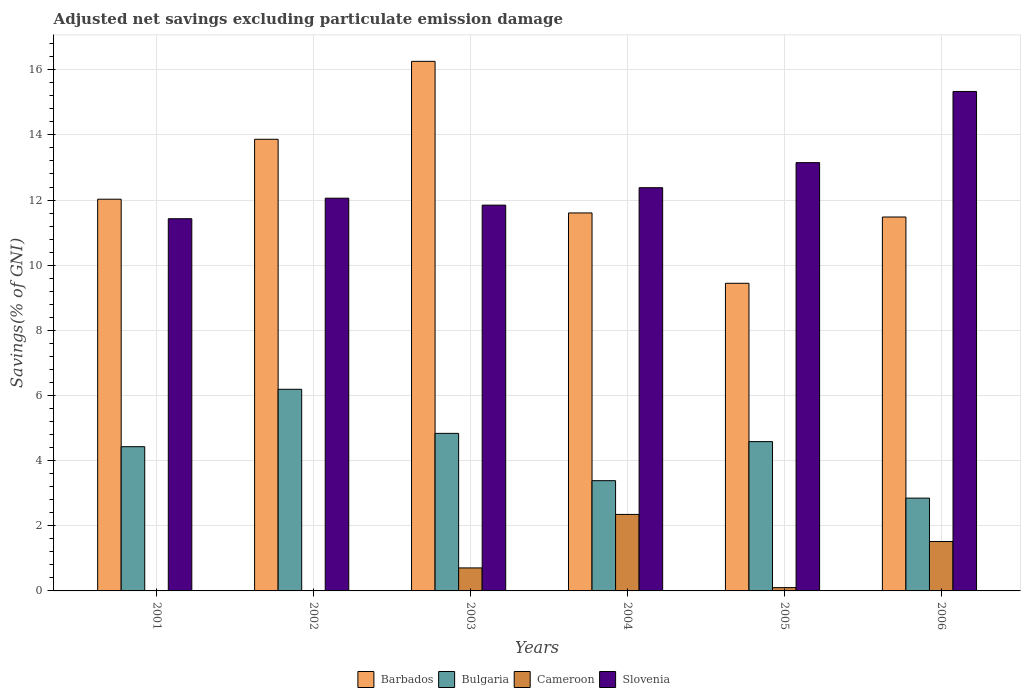How many groups of bars are there?
Provide a short and direct response. 6. How many bars are there on the 1st tick from the left?
Provide a short and direct response. 3. What is the adjusted net savings in Bulgaria in 2001?
Make the answer very short. 4.43. Across all years, what is the maximum adjusted net savings in Bulgaria?
Offer a very short reply. 6.19. Across all years, what is the minimum adjusted net savings in Slovenia?
Your response must be concise. 11.43. What is the total adjusted net savings in Barbados in the graph?
Offer a very short reply. 74.67. What is the difference between the adjusted net savings in Barbados in 2004 and that in 2006?
Your response must be concise. 0.12. What is the difference between the adjusted net savings in Barbados in 2005 and the adjusted net savings in Bulgaria in 2004?
Make the answer very short. 6.06. What is the average adjusted net savings in Barbados per year?
Make the answer very short. 12.45. In the year 2006, what is the difference between the adjusted net savings in Slovenia and adjusted net savings in Barbados?
Ensure brevity in your answer.  3.85. In how many years, is the adjusted net savings in Cameroon greater than 5.6 %?
Your response must be concise. 0. What is the ratio of the adjusted net savings in Cameroon in 2004 to that in 2005?
Your response must be concise. 23.28. Is the adjusted net savings in Barbados in 2001 less than that in 2002?
Give a very brief answer. Yes. Is the difference between the adjusted net savings in Slovenia in 2002 and 2006 greater than the difference between the adjusted net savings in Barbados in 2002 and 2006?
Keep it short and to the point. No. What is the difference between the highest and the second highest adjusted net savings in Slovenia?
Offer a very short reply. 2.19. What is the difference between the highest and the lowest adjusted net savings in Barbados?
Offer a very short reply. 6.81. Are all the bars in the graph horizontal?
Keep it short and to the point. No. Are the values on the major ticks of Y-axis written in scientific E-notation?
Give a very brief answer. No. Does the graph contain grids?
Offer a terse response. Yes. How are the legend labels stacked?
Keep it short and to the point. Horizontal. What is the title of the graph?
Offer a very short reply. Adjusted net savings excluding particulate emission damage. Does "Burkina Faso" appear as one of the legend labels in the graph?
Provide a short and direct response. No. What is the label or title of the Y-axis?
Keep it short and to the point. Savings(% of GNI). What is the Savings(% of GNI) in Barbados in 2001?
Your response must be concise. 12.03. What is the Savings(% of GNI) in Bulgaria in 2001?
Your answer should be very brief. 4.43. What is the Savings(% of GNI) of Cameroon in 2001?
Ensure brevity in your answer.  0. What is the Savings(% of GNI) in Slovenia in 2001?
Your answer should be very brief. 11.43. What is the Savings(% of GNI) of Barbados in 2002?
Keep it short and to the point. 13.87. What is the Savings(% of GNI) of Bulgaria in 2002?
Keep it short and to the point. 6.19. What is the Savings(% of GNI) of Cameroon in 2002?
Give a very brief answer. 0. What is the Savings(% of GNI) of Slovenia in 2002?
Offer a very short reply. 12.06. What is the Savings(% of GNI) of Barbados in 2003?
Your answer should be very brief. 16.26. What is the Savings(% of GNI) of Bulgaria in 2003?
Keep it short and to the point. 4.84. What is the Savings(% of GNI) of Cameroon in 2003?
Provide a short and direct response. 0.71. What is the Savings(% of GNI) in Slovenia in 2003?
Provide a short and direct response. 11.84. What is the Savings(% of GNI) of Barbados in 2004?
Ensure brevity in your answer.  11.6. What is the Savings(% of GNI) of Bulgaria in 2004?
Offer a terse response. 3.38. What is the Savings(% of GNI) of Cameroon in 2004?
Give a very brief answer. 2.35. What is the Savings(% of GNI) of Slovenia in 2004?
Your answer should be very brief. 12.38. What is the Savings(% of GNI) in Barbados in 2005?
Provide a short and direct response. 9.44. What is the Savings(% of GNI) of Bulgaria in 2005?
Offer a very short reply. 4.58. What is the Savings(% of GNI) of Cameroon in 2005?
Ensure brevity in your answer.  0.1. What is the Savings(% of GNI) in Slovenia in 2005?
Provide a succinct answer. 13.15. What is the Savings(% of GNI) of Barbados in 2006?
Make the answer very short. 11.48. What is the Savings(% of GNI) of Bulgaria in 2006?
Provide a succinct answer. 2.85. What is the Savings(% of GNI) in Cameroon in 2006?
Your response must be concise. 1.52. What is the Savings(% of GNI) of Slovenia in 2006?
Your response must be concise. 15.33. Across all years, what is the maximum Savings(% of GNI) in Barbados?
Give a very brief answer. 16.26. Across all years, what is the maximum Savings(% of GNI) in Bulgaria?
Your answer should be compact. 6.19. Across all years, what is the maximum Savings(% of GNI) in Cameroon?
Your response must be concise. 2.35. Across all years, what is the maximum Savings(% of GNI) of Slovenia?
Keep it short and to the point. 15.33. Across all years, what is the minimum Savings(% of GNI) in Barbados?
Keep it short and to the point. 9.44. Across all years, what is the minimum Savings(% of GNI) of Bulgaria?
Your response must be concise. 2.85. Across all years, what is the minimum Savings(% of GNI) in Cameroon?
Your response must be concise. 0. Across all years, what is the minimum Savings(% of GNI) in Slovenia?
Keep it short and to the point. 11.43. What is the total Savings(% of GNI) in Barbados in the graph?
Offer a terse response. 74.67. What is the total Savings(% of GNI) of Bulgaria in the graph?
Your response must be concise. 26.27. What is the total Savings(% of GNI) in Cameroon in the graph?
Your answer should be compact. 4.67. What is the total Savings(% of GNI) of Slovenia in the graph?
Your response must be concise. 76.19. What is the difference between the Savings(% of GNI) of Barbados in 2001 and that in 2002?
Provide a succinct answer. -1.84. What is the difference between the Savings(% of GNI) of Bulgaria in 2001 and that in 2002?
Give a very brief answer. -1.76. What is the difference between the Savings(% of GNI) in Slovenia in 2001 and that in 2002?
Your answer should be compact. -0.63. What is the difference between the Savings(% of GNI) of Barbados in 2001 and that in 2003?
Your answer should be compact. -4.23. What is the difference between the Savings(% of GNI) in Bulgaria in 2001 and that in 2003?
Give a very brief answer. -0.41. What is the difference between the Savings(% of GNI) of Slovenia in 2001 and that in 2003?
Provide a succinct answer. -0.42. What is the difference between the Savings(% of GNI) in Barbados in 2001 and that in 2004?
Ensure brevity in your answer.  0.42. What is the difference between the Savings(% of GNI) of Bulgaria in 2001 and that in 2004?
Offer a terse response. 1.04. What is the difference between the Savings(% of GNI) of Slovenia in 2001 and that in 2004?
Give a very brief answer. -0.95. What is the difference between the Savings(% of GNI) in Barbados in 2001 and that in 2005?
Ensure brevity in your answer.  2.58. What is the difference between the Savings(% of GNI) in Bulgaria in 2001 and that in 2005?
Your answer should be very brief. -0.16. What is the difference between the Savings(% of GNI) in Slovenia in 2001 and that in 2005?
Ensure brevity in your answer.  -1.72. What is the difference between the Savings(% of GNI) of Barbados in 2001 and that in 2006?
Offer a very short reply. 0.55. What is the difference between the Savings(% of GNI) of Bulgaria in 2001 and that in 2006?
Ensure brevity in your answer.  1.58. What is the difference between the Savings(% of GNI) of Slovenia in 2001 and that in 2006?
Offer a very short reply. -3.91. What is the difference between the Savings(% of GNI) of Barbados in 2002 and that in 2003?
Provide a succinct answer. -2.39. What is the difference between the Savings(% of GNI) in Bulgaria in 2002 and that in 2003?
Give a very brief answer. 1.35. What is the difference between the Savings(% of GNI) in Slovenia in 2002 and that in 2003?
Provide a short and direct response. 0.21. What is the difference between the Savings(% of GNI) of Barbados in 2002 and that in 2004?
Keep it short and to the point. 2.26. What is the difference between the Savings(% of GNI) in Bulgaria in 2002 and that in 2004?
Give a very brief answer. 2.81. What is the difference between the Savings(% of GNI) in Slovenia in 2002 and that in 2004?
Your response must be concise. -0.32. What is the difference between the Savings(% of GNI) in Barbados in 2002 and that in 2005?
Your answer should be compact. 4.42. What is the difference between the Savings(% of GNI) in Bulgaria in 2002 and that in 2005?
Offer a terse response. 1.61. What is the difference between the Savings(% of GNI) of Slovenia in 2002 and that in 2005?
Keep it short and to the point. -1.09. What is the difference between the Savings(% of GNI) in Barbados in 2002 and that in 2006?
Keep it short and to the point. 2.39. What is the difference between the Savings(% of GNI) in Bulgaria in 2002 and that in 2006?
Ensure brevity in your answer.  3.34. What is the difference between the Savings(% of GNI) in Slovenia in 2002 and that in 2006?
Your answer should be very brief. -3.28. What is the difference between the Savings(% of GNI) in Barbados in 2003 and that in 2004?
Provide a short and direct response. 4.65. What is the difference between the Savings(% of GNI) of Bulgaria in 2003 and that in 2004?
Keep it short and to the point. 1.45. What is the difference between the Savings(% of GNI) of Cameroon in 2003 and that in 2004?
Your answer should be compact. -1.64. What is the difference between the Savings(% of GNI) in Slovenia in 2003 and that in 2004?
Your answer should be compact. -0.54. What is the difference between the Savings(% of GNI) of Barbados in 2003 and that in 2005?
Ensure brevity in your answer.  6.81. What is the difference between the Savings(% of GNI) of Bulgaria in 2003 and that in 2005?
Give a very brief answer. 0.25. What is the difference between the Savings(% of GNI) of Cameroon in 2003 and that in 2005?
Keep it short and to the point. 0.61. What is the difference between the Savings(% of GNI) of Slovenia in 2003 and that in 2005?
Ensure brevity in your answer.  -1.3. What is the difference between the Savings(% of GNI) of Barbados in 2003 and that in 2006?
Keep it short and to the point. 4.78. What is the difference between the Savings(% of GNI) in Bulgaria in 2003 and that in 2006?
Offer a very short reply. 1.99. What is the difference between the Savings(% of GNI) in Cameroon in 2003 and that in 2006?
Offer a very short reply. -0.81. What is the difference between the Savings(% of GNI) in Slovenia in 2003 and that in 2006?
Provide a short and direct response. -3.49. What is the difference between the Savings(% of GNI) in Barbados in 2004 and that in 2005?
Offer a terse response. 2.16. What is the difference between the Savings(% of GNI) of Bulgaria in 2004 and that in 2005?
Provide a succinct answer. -1.2. What is the difference between the Savings(% of GNI) of Cameroon in 2004 and that in 2005?
Make the answer very short. 2.25. What is the difference between the Savings(% of GNI) in Slovenia in 2004 and that in 2005?
Your answer should be very brief. -0.77. What is the difference between the Savings(% of GNI) of Barbados in 2004 and that in 2006?
Provide a short and direct response. 0.12. What is the difference between the Savings(% of GNI) in Bulgaria in 2004 and that in 2006?
Your answer should be compact. 0.54. What is the difference between the Savings(% of GNI) in Cameroon in 2004 and that in 2006?
Your response must be concise. 0.83. What is the difference between the Savings(% of GNI) of Slovenia in 2004 and that in 2006?
Ensure brevity in your answer.  -2.95. What is the difference between the Savings(% of GNI) of Barbados in 2005 and that in 2006?
Keep it short and to the point. -2.03. What is the difference between the Savings(% of GNI) of Bulgaria in 2005 and that in 2006?
Give a very brief answer. 1.73. What is the difference between the Savings(% of GNI) in Cameroon in 2005 and that in 2006?
Your answer should be compact. -1.42. What is the difference between the Savings(% of GNI) of Slovenia in 2005 and that in 2006?
Your answer should be very brief. -2.19. What is the difference between the Savings(% of GNI) of Barbados in 2001 and the Savings(% of GNI) of Bulgaria in 2002?
Your response must be concise. 5.84. What is the difference between the Savings(% of GNI) of Barbados in 2001 and the Savings(% of GNI) of Slovenia in 2002?
Ensure brevity in your answer.  -0.03. What is the difference between the Savings(% of GNI) of Bulgaria in 2001 and the Savings(% of GNI) of Slovenia in 2002?
Provide a succinct answer. -7.63. What is the difference between the Savings(% of GNI) in Barbados in 2001 and the Savings(% of GNI) in Bulgaria in 2003?
Give a very brief answer. 7.19. What is the difference between the Savings(% of GNI) in Barbados in 2001 and the Savings(% of GNI) in Cameroon in 2003?
Your response must be concise. 11.32. What is the difference between the Savings(% of GNI) in Barbados in 2001 and the Savings(% of GNI) in Slovenia in 2003?
Give a very brief answer. 0.18. What is the difference between the Savings(% of GNI) in Bulgaria in 2001 and the Savings(% of GNI) in Cameroon in 2003?
Offer a terse response. 3.72. What is the difference between the Savings(% of GNI) of Bulgaria in 2001 and the Savings(% of GNI) of Slovenia in 2003?
Keep it short and to the point. -7.42. What is the difference between the Savings(% of GNI) of Barbados in 2001 and the Savings(% of GNI) of Bulgaria in 2004?
Your answer should be compact. 8.64. What is the difference between the Savings(% of GNI) of Barbados in 2001 and the Savings(% of GNI) of Cameroon in 2004?
Ensure brevity in your answer.  9.68. What is the difference between the Savings(% of GNI) in Barbados in 2001 and the Savings(% of GNI) in Slovenia in 2004?
Your response must be concise. -0.35. What is the difference between the Savings(% of GNI) in Bulgaria in 2001 and the Savings(% of GNI) in Cameroon in 2004?
Provide a short and direct response. 2.08. What is the difference between the Savings(% of GNI) of Bulgaria in 2001 and the Savings(% of GNI) of Slovenia in 2004?
Your answer should be compact. -7.95. What is the difference between the Savings(% of GNI) in Barbados in 2001 and the Savings(% of GNI) in Bulgaria in 2005?
Your response must be concise. 7.44. What is the difference between the Savings(% of GNI) of Barbados in 2001 and the Savings(% of GNI) of Cameroon in 2005?
Offer a terse response. 11.92. What is the difference between the Savings(% of GNI) of Barbados in 2001 and the Savings(% of GNI) of Slovenia in 2005?
Your answer should be compact. -1.12. What is the difference between the Savings(% of GNI) of Bulgaria in 2001 and the Savings(% of GNI) of Cameroon in 2005?
Keep it short and to the point. 4.33. What is the difference between the Savings(% of GNI) in Bulgaria in 2001 and the Savings(% of GNI) in Slovenia in 2005?
Your answer should be very brief. -8.72. What is the difference between the Savings(% of GNI) in Barbados in 2001 and the Savings(% of GNI) in Bulgaria in 2006?
Your answer should be very brief. 9.18. What is the difference between the Savings(% of GNI) of Barbados in 2001 and the Savings(% of GNI) of Cameroon in 2006?
Your answer should be compact. 10.51. What is the difference between the Savings(% of GNI) in Barbados in 2001 and the Savings(% of GNI) in Slovenia in 2006?
Your response must be concise. -3.31. What is the difference between the Savings(% of GNI) of Bulgaria in 2001 and the Savings(% of GNI) of Cameroon in 2006?
Your answer should be very brief. 2.91. What is the difference between the Savings(% of GNI) in Bulgaria in 2001 and the Savings(% of GNI) in Slovenia in 2006?
Give a very brief answer. -10.91. What is the difference between the Savings(% of GNI) in Barbados in 2002 and the Savings(% of GNI) in Bulgaria in 2003?
Ensure brevity in your answer.  9.03. What is the difference between the Savings(% of GNI) in Barbados in 2002 and the Savings(% of GNI) in Cameroon in 2003?
Make the answer very short. 13.16. What is the difference between the Savings(% of GNI) in Barbados in 2002 and the Savings(% of GNI) in Slovenia in 2003?
Provide a short and direct response. 2.02. What is the difference between the Savings(% of GNI) in Bulgaria in 2002 and the Savings(% of GNI) in Cameroon in 2003?
Your response must be concise. 5.48. What is the difference between the Savings(% of GNI) of Bulgaria in 2002 and the Savings(% of GNI) of Slovenia in 2003?
Ensure brevity in your answer.  -5.65. What is the difference between the Savings(% of GNI) in Barbados in 2002 and the Savings(% of GNI) in Bulgaria in 2004?
Keep it short and to the point. 10.48. What is the difference between the Savings(% of GNI) in Barbados in 2002 and the Savings(% of GNI) in Cameroon in 2004?
Offer a very short reply. 11.52. What is the difference between the Savings(% of GNI) of Barbados in 2002 and the Savings(% of GNI) of Slovenia in 2004?
Your answer should be compact. 1.49. What is the difference between the Savings(% of GNI) of Bulgaria in 2002 and the Savings(% of GNI) of Cameroon in 2004?
Your answer should be very brief. 3.84. What is the difference between the Savings(% of GNI) of Bulgaria in 2002 and the Savings(% of GNI) of Slovenia in 2004?
Your response must be concise. -6.19. What is the difference between the Savings(% of GNI) of Barbados in 2002 and the Savings(% of GNI) of Bulgaria in 2005?
Give a very brief answer. 9.28. What is the difference between the Savings(% of GNI) of Barbados in 2002 and the Savings(% of GNI) of Cameroon in 2005?
Your response must be concise. 13.76. What is the difference between the Savings(% of GNI) of Barbados in 2002 and the Savings(% of GNI) of Slovenia in 2005?
Your answer should be compact. 0.72. What is the difference between the Savings(% of GNI) in Bulgaria in 2002 and the Savings(% of GNI) in Cameroon in 2005?
Ensure brevity in your answer.  6.09. What is the difference between the Savings(% of GNI) in Bulgaria in 2002 and the Savings(% of GNI) in Slovenia in 2005?
Your answer should be very brief. -6.96. What is the difference between the Savings(% of GNI) in Barbados in 2002 and the Savings(% of GNI) in Bulgaria in 2006?
Offer a very short reply. 11.02. What is the difference between the Savings(% of GNI) of Barbados in 2002 and the Savings(% of GNI) of Cameroon in 2006?
Your answer should be compact. 12.35. What is the difference between the Savings(% of GNI) of Barbados in 2002 and the Savings(% of GNI) of Slovenia in 2006?
Provide a short and direct response. -1.47. What is the difference between the Savings(% of GNI) in Bulgaria in 2002 and the Savings(% of GNI) in Cameroon in 2006?
Your answer should be compact. 4.67. What is the difference between the Savings(% of GNI) of Bulgaria in 2002 and the Savings(% of GNI) of Slovenia in 2006?
Your answer should be very brief. -9.14. What is the difference between the Savings(% of GNI) in Barbados in 2003 and the Savings(% of GNI) in Bulgaria in 2004?
Your answer should be very brief. 12.87. What is the difference between the Savings(% of GNI) in Barbados in 2003 and the Savings(% of GNI) in Cameroon in 2004?
Provide a short and direct response. 13.91. What is the difference between the Savings(% of GNI) of Barbados in 2003 and the Savings(% of GNI) of Slovenia in 2004?
Your answer should be compact. 3.88. What is the difference between the Savings(% of GNI) of Bulgaria in 2003 and the Savings(% of GNI) of Cameroon in 2004?
Your answer should be very brief. 2.49. What is the difference between the Savings(% of GNI) in Bulgaria in 2003 and the Savings(% of GNI) in Slovenia in 2004?
Make the answer very short. -7.54. What is the difference between the Savings(% of GNI) in Cameroon in 2003 and the Savings(% of GNI) in Slovenia in 2004?
Provide a short and direct response. -11.67. What is the difference between the Savings(% of GNI) in Barbados in 2003 and the Savings(% of GNI) in Bulgaria in 2005?
Your response must be concise. 11.67. What is the difference between the Savings(% of GNI) of Barbados in 2003 and the Savings(% of GNI) of Cameroon in 2005?
Your answer should be compact. 16.16. What is the difference between the Savings(% of GNI) in Barbados in 2003 and the Savings(% of GNI) in Slovenia in 2005?
Offer a very short reply. 3.11. What is the difference between the Savings(% of GNI) of Bulgaria in 2003 and the Savings(% of GNI) of Cameroon in 2005?
Offer a terse response. 4.74. What is the difference between the Savings(% of GNI) in Bulgaria in 2003 and the Savings(% of GNI) in Slovenia in 2005?
Your response must be concise. -8.31. What is the difference between the Savings(% of GNI) of Cameroon in 2003 and the Savings(% of GNI) of Slovenia in 2005?
Ensure brevity in your answer.  -12.44. What is the difference between the Savings(% of GNI) in Barbados in 2003 and the Savings(% of GNI) in Bulgaria in 2006?
Keep it short and to the point. 13.41. What is the difference between the Savings(% of GNI) in Barbados in 2003 and the Savings(% of GNI) in Cameroon in 2006?
Keep it short and to the point. 14.74. What is the difference between the Savings(% of GNI) of Barbados in 2003 and the Savings(% of GNI) of Slovenia in 2006?
Offer a very short reply. 0.92. What is the difference between the Savings(% of GNI) of Bulgaria in 2003 and the Savings(% of GNI) of Cameroon in 2006?
Your answer should be compact. 3.32. What is the difference between the Savings(% of GNI) in Bulgaria in 2003 and the Savings(% of GNI) in Slovenia in 2006?
Provide a succinct answer. -10.5. What is the difference between the Savings(% of GNI) in Cameroon in 2003 and the Savings(% of GNI) in Slovenia in 2006?
Make the answer very short. -14.63. What is the difference between the Savings(% of GNI) in Barbados in 2004 and the Savings(% of GNI) in Bulgaria in 2005?
Your answer should be very brief. 7.02. What is the difference between the Savings(% of GNI) of Barbados in 2004 and the Savings(% of GNI) of Cameroon in 2005?
Keep it short and to the point. 11.5. What is the difference between the Savings(% of GNI) of Barbados in 2004 and the Savings(% of GNI) of Slovenia in 2005?
Ensure brevity in your answer.  -1.54. What is the difference between the Savings(% of GNI) in Bulgaria in 2004 and the Savings(% of GNI) in Cameroon in 2005?
Your answer should be compact. 3.28. What is the difference between the Savings(% of GNI) in Bulgaria in 2004 and the Savings(% of GNI) in Slovenia in 2005?
Make the answer very short. -9.76. What is the difference between the Savings(% of GNI) in Cameroon in 2004 and the Savings(% of GNI) in Slovenia in 2005?
Ensure brevity in your answer.  -10.8. What is the difference between the Savings(% of GNI) in Barbados in 2004 and the Savings(% of GNI) in Bulgaria in 2006?
Your response must be concise. 8.75. What is the difference between the Savings(% of GNI) in Barbados in 2004 and the Savings(% of GNI) in Cameroon in 2006?
Provide a short and direct response. 10.09. What is the difference between the Savings(% of GNI) in Barbados in 2004 and the Savings(% of GNI) in Slovenia in 2006?
Ensure brevity in your answer.  -3.73. What is the difference between the Savings(% of GNI) in Bulgaria in 2004 and the Savings(% of GNI) in Cameroon in 2006?
Your answer should be very brief. 1.87. What is the difference between the Savings(% of GNI) in Bulgaria in 2004 and the Savings(% of GNI) in Slovenia in 2006?
Provide a succinct answer. -11.95. What is the difference between the Savings(% of GNI) of Cameroon in 2004 and the Savings(% of GNI) of Slovenia in 2006?
Your response must be concise. -12.98. What is the difference between the Savings(% of GNI) in Barbados in 2005 and the Savings(% of GNI) in Bulgaria in 2006?
Provide a succinct answer. 6.59. What is the difference between the Savings(% of GNI) in Barbados in 2005 and the Savings(% of GNI) in Cameroon in 2006?
Your answer should be very brief. 7.93. What is the difference between the Savings(% of GNI) of Barbados in 2005 and the Savings(% of GNI) of Slovenia in 2006?
Provide a short and direct response. -5.89. What is the difference between the Savings(% of GNI) of Bulgaria in 2005 and the Savings(% of GNI) of Cameroon in 2006?
Provide a succinct answer. 3.07. What is the difference between the Savings(% of GNI) of Bulgaria in 2005 and the Savings(% of GNI) of Slovenia in 2006?
Your answer should be compact. -10.75. What is the difference between the Savings(% of GNI) in Cameroon in 2005 and the Savings(% of GNI) in Slovenia in 2006?
Your answer should be compact. -15.23. What is the average Savings(% of GNI) in Barbados per year?
Provide a short and direct response. 12.45. What is the average Savings(% of GNI) of Bulgaria per year?
Your answer should be very brief. 4.38. What is the average Savings(% of GNI) of Cameroon per year?
Your answer should be very brief. 0.78. What is the average Savings(% of GNI) of Slovenia per year?
Keep it short and to the point. 12.7. In the year 2001, what is the difference between the Savings(% of GNI) in Barbados and Savings(% of GNI) in Bulgaria?
Your response must be concise. 7.6. In the year 2001, what is the difference between the Savings(% of GNI) in Barbados and Savings(% of GNI) in Slovenia?
Offer a very short reply. 0.6. In the year 2001, what is the difference between the Savings(% of GNI) of Bulgaria and Savings(% of GNI) of Slovenia?
Give a very brief answer. -7. In the year 2002, what is the difference between the Savings(% of GNI) in Barbados and Savings(% of GNI) in Bulgaria?
Provide a succinct answer. 7.68. In the year 2002, what is the difference between the Savings(% of GNI) in Barbados and Savings(% of GNI) in Slovenia?
Offer a very short reply. 1.81. In the year 2002, what is the difference between the Savings(% of GNI) of Bulgaria and Savings(% of GNI) of Slovenia?
Your answer should be very brief. -5.87. In the year 2003, what is the difference between the Savings(% of GNI) in Barbados and Savings(% of GNI) in Bulgaria?
Make the answer very short. 11.42. In the year 2003, what is the difference between the Savings(% of GNI) in Barbados and Savings(% of GNI) in Cameroon?
Make the answer very short. 15.55. In the year 2003, what is the difference between the Savings(% of GNI) in Barbados and Savings(% of GNI) in Slovenia?
Give a very brief answer. 4.41. In the year 2003, what is the difference between the Savings(% of GNI) of Bulgaria and Savings(% of GNI) of Cameroon?
Make the answer very short. 4.13. In the year 2003, what is the difference between the Savings(% of GNI) of Bulgaria and Savings(% of GNI) of Slovenia?
Provide a short and direct response. -7.01. In the year 2003, what is the difference between the Savings(% of GNI) of Cameroon and Savings(% of GNI) of Slovenia?
Offer a terse response. -11.14. In the year 2004, what is the difference between the Savings(% of GNI) in Barbados and Savings(% of GNI) in Bulgaria?
Your response must be concise. 8.22. In the year 2004, what is the difference between the Savings(% of GNI) of Barbados and Savings(% of GNI) of Cameroon?
Ensure brevity in your answer.  9.25. In the year 2004, what is the difference between the Savings(% of GNI) in Barbados and Savings(% of GNI) in Slovenia?
Your response must be concise. -0.78. In the year 2004, what is the difference between the Savings(% of GNI) of Bulgaria and Savings(% of GNI) of Cameroon?
Make the answer very short. 1.04. In the year 2004, what is the difference between the Savings(% of GNI) in Bulgaria and Savings(% of GNI) in Slovenia?
Ensure brevity in your answer.  -8.99. In the year 2004, what is the difference between the Savings(% of GNI) in Cameroon and Savings(% of GNI) in Slovenia?
Your answer should be very brief. -10.03. In the year 2005, what is the difference between the Savings(% of GNI) in Barbados and Savings(% of GNI) in Bulgaria?
Provide a short and direct response. 4.86. In the year 2005, what is the difference between the Savings(% of GNI) in Barbados and Savings(% of GNI) in Cameroon?
Give a very brief answer. 9.34. In the year 2005, what is the difference between the Savings(% of GNI) of Barbados and Savings(% of GNI) of Slovenia?
Provide a succinct answer. -3.7. In the year 2005, what is the difference between the Savings(% of GNI) in Bulgaria and Savings(% of GNI) in Cameroon?
Keep it short and to the point. 4.48. In the year 2005, what is the difference between the Savings(% of GNI) of Bulgaria and Savings(% of GNI) of Slovenia?
Provide a succinct answer. -8.56. In the year 2005, what is the difference between the Savings(% of GNI) of Cameroon and Savings(% of GNI) of Slovenia?
Provide a succinct answer. -13.05. In the year 2006, what is the difference between the Savings(% of GNI) in Barbados and Savings(% of GNI) in Bulgaria?
Your answer should be compact. 8.63. In the year 2006, what is the difference between the Savings(% of GNI) of Barbados and Savings(% of GNI) of Cameroon?
Your answer should be compact. 9.96. In the year 2006, what is the difference between the Savings(% of GNI) in Barbados and Savings(% of GNI) in Slovenia?
Ensure brevity in your answer.  -3.85. In the year 2006, what is the difference between the Savings(% of GNI) of Bulgaria and Savings(% of GNI) of Cameroon?
Your answer should be very brief. 1.33. In the year 2006, what is the difference between the Savings(% of GNI) of Bulgaria and Savings(% of GNI) of Slovenia?
Your response must be concise. -12.48. In the year 2006, what is the difference between the Savings(% of GNI) in Cameroon and Savings(% of GNI) in Slovenia?
Make the answer very short. -13.82. What is the ratio of the Savings(% of GNI) of Barbados in 2001 to that in 2002?
Keep it short and to the point. 0.87. What is the ratio of the Savings(% of GNI) in Bulgaria in 2001 to that in 2002?
Offer a very short reply. 0.72. What is the ratio of the Savings(% of GNI) in Slovenia in 2001 to that in 2002?
Provide a succinct answer. 0.95. What is the ratio of the Savings(% of GNI) in Barbados in 2001 to that in 2003?
Keep it short and to the point. 0.74. What is the ratio of the Savings(% of GNI) in Bulgaria in 2001 to that in 2003?
Offer a terse response. 0.92. What is the ratio of the Savings(% of GNI) of Slovenia in 2001 to that in 2003?
Your answer should be very brief. 0.96. What is the ratio of the Savings(% of GNI) in Barbados in 2001 to that in 2004?
Offer a very short reply. 1.04. What is the ratio of the Savings(% of GNI) of Bulgaria in 2001 to that in 2004?
Offer a very short reply. 1.31. What is the ratio of the Savings(% of GNI) of Slovenia in 2001 to that in 2004?
Offer a very short reply. 0.92. What is the ratio of the Savings(% of GNI) of Barbados in 2001 to that in 2005?
Provide a short and direct response. 1.27. What is the ratio of the Savings(% of GNI) of Slovenia in 2001 to that in 2005?
Your answer should be compact. 0.87. What is the ratio of the Savings(% of GNI) of Barbados in 2001 to that in 2006?
Your answer should be very brief. 1.05. What is the ratio of the Savings(% of GNI) of Bulgaria in 2001 to that in 2006?
Your answer should be compact. 1.55. What is the ratio of the Savings(% of GNI) of Slovenia in 2001 to that in 2006?
Ensure brevity in your answer.  0.75. What is the ratio of the Savings(% of GNI) in Barbados in 2002 to that in 2003?
Offer a terse response. 0.85. What is the ratio of the Savings(% of GNI) in Bulgaria in 2002 to that in 2003?
Provide a succinct answer. 1.28. What is the ratio of the Savings(% of GNI) of Barbados in 2002 to that in 2004?
Your answer should be very brief. 1.19. What is the ratio of the Savings(% of GNI) in Bulgaria in 2002 to that in 2004?
Offer a very short reply. 1.83. What is the ratio of the Savings(% of GNI) in Slovenia in 2002 to that in 2004?
Offer a very short reply. 0.97. What is the ratio of the Savings(% of GNI) in Barbados in 2002 to that in 2005?
Keep it short and to the point. 1.47. What is the ratio of the Savings(% of GNI) of Bulgaria in 2002 to that in 2005?
Your answer should be compact. 1.35. What is the ratio of the Savings(% of GNI) of Slovenia in 2002 to that in 2005?
Your response must be concise. 0.92. What is the ratio of the Savings(% of GNI) of Barbados in 2002 to that in 2006?
Your response must be concise. 1.21. What is the ratio of the Savings(% of GNI) of Bulgaria in 2002 to that in 2006?
Ensure brevity in your answer.  2.17. What is the ratio of the Savings(% of GNI) of Slovenia in 2002 to that in 2006?
Give a very brief answer. 0.79. What is the ratio of the Savings(% of GNI) of Barbados in 2003 to that in 2004?
Give a very brief answer. 1.4. What is the ratio of the Savings(% of GNI) of Bulgaria in 2003 to that in 2004?
Provide a short and direct response. 1.43. What is the ratio of the Savings(% of GNI) in Cameroon in 2003 to that in 2004?
Make the answer very short. 0.3. What is the ratio of the Savings(% of GNI) of Slovenia in 2003 to that in 2004?
Make the answer very short. 0.96. What is the ratio of the Savings(% of GNI) in Barbados in 2003 to that in 2005?
Ensure brevity in your answer.  1.72. What is the ratio of the Savings(% of GNI) in Bulgaria in 2003 to that in 2005?
Keep it short and to the point. 1.06. What is the ratio of the Savings(% of GNI) in Cameroon in 2003 to that in 2005?
Your answer should be very brief. 7. What is the ratio of the Savings(% of GNI) of Slovenia in 2003 to that in 2005?
Your answer should be very brief. 0.9. What is the ratio of the Savings(% of GNI) of Barbados in 2003 to that in 2006?
Your answer should be very brief. 1.42. What is the ratio of the Savings(% of GNI) of Bulgaria in 2003 to that in 2006?
Keep it short and to the point. 1.7. What is the ratio of the Savings(% of GNI) in Cameroon in 2003 to that in 2006?
Provide a short and direct response. 0.47. What is the ratio of the Savings(% of GNI) of Slovenia in 2003 to that in 2006?
Your response must be concise. 0.77. What is the ratio of the Savings(% of GNI) in Barbados in 2004 to that in 2005?
Offer a very short reply. 1.23. What is the ratio of the Savings(% of GNI) in Bulgaria in 2004 to that in 2005?
Provide a succinct answer. 0.74. What is the ratio of the Savings(% of GNI) of Cameroon in 2004 to that in 2005?
Give a very brief answer. 23.28. What is the ratio of the Savings(% of GNI) of Slovenia in 2004 to that in 2005?
Your response must be concise. 0.94. What is the ratio of the Savings(% of GNI) of Barbados in 2004 to that in 2006?
Ensure brevity in your answer.  1.01. What is the ratio of the Savings(% of GNI) of Bulgaria in 2004 to that in 2006?
Your answer should be compact. 1.19. What is the ratio of the Savings(% of GNI) in Cameroon in 2004 to that in 2006?
Your response must be concise. 1.55. What is the ratio of the Savings(% of GNI) in Slovenia in 2004 to that in 2006?
Offer a terse response. 0.81. What is the ratio of the Savings(% of GNI) in Barbados in 2005 to that in 2006?
Provide a succinct answer. 0.82. What is the ratio of the Savings(% of GNI) in Bulgaria in 2005 to that in 2006?
Give a very brief answer. 1.61. What is the ratio of the Savings(% of GNI) of Cameroon in 2005 to that in 2006?
Your answer should be very brief. 0.07. What is the ratio of the Savings(% of GNI) in Slovenia in 2005 to that in 2006?
Ensure brevity in your answer.  0.86. What is the difference between the highest and the second highest Savings(% of GNI) of Barbados?
Make the answer very short. 2.39. What is the difference between the highest and the second highest Savings(% of GNI) in Bulgaria?
Your answer should be compact. 1.35. What is the difference between the highest and the second highest Savings(% of GNI) of Cameroon?
Keep it short and to the point. 0.83. What is the difference between the highest and the second highest Savings(% of GNI) in Slovenia?
Provide a short and direct response. 2.19. What is the difference between the highest and the lowest Savings(% of GNI) in Barbados?
Make the answer very short. 6.81. What is the difference between the highest and the lowest Savings(% of GNI) in Bulgaria?
Ensure brevity in your answer.  3.34. What is the difference between the highest and the lowest Savings(% of GNI) in Cameroon?
Your answer should be compact. 2.35. What is the difference between the highest and the lowest Savings(% of GNI) in Slovenia?
Offer a terse response. 3.91. 